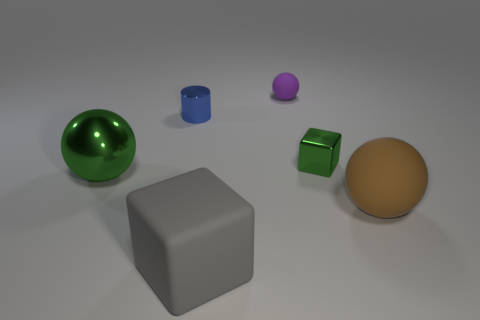Add 1 tiny blue objects. How many objects exist? 7 Subtract all matte balls. How many balls are left? 1 Subtract all purple spheres. How many spheres are left? 2 Subtract all cubes. How many objects are left? 4 Subtract 2 spheres. How many spheres are left? 1 Subtract all brown cubes. Subtract all purple balls. How many cubes are left? 2 Subtract all big yellow metal balls. Subtract all metal cubes. How many objects are left? 5 Add 4 small spheres. How many small spheres are left? 5 Add 4 tiny blocks. How many tiny blocks exist? 5 Subtract 0 blue blocks. How many objects are left? 6 